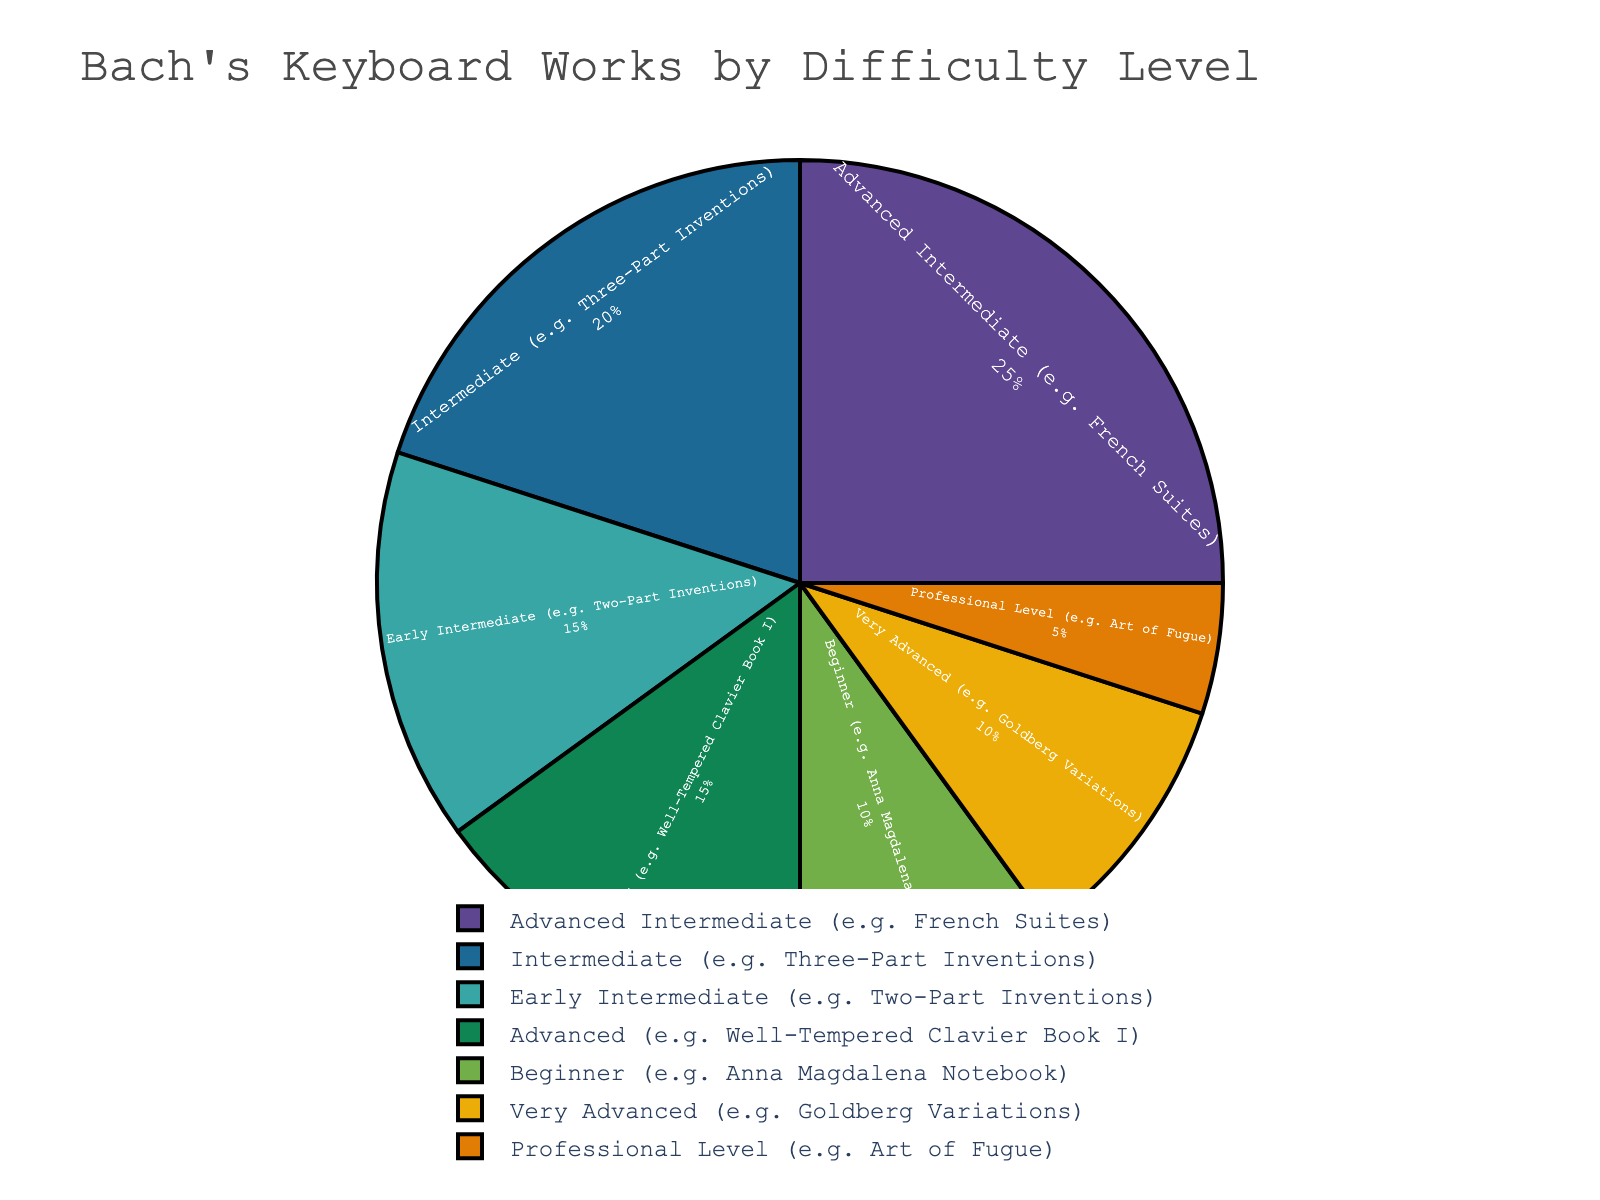What's the percentage of Bach's keyboard works that are at or below Intermediate level of difficulty? Sum the percentages of Beginner, Early Intermediate, and Intermediate levels. 10% (Beginner) + 15% (Early Intermediate) + 20% (Intermediate) = 45%
Answer: 45% Which difficulty level has the highest percentage of Bach's keyboard works? The chart shows that Advanced Intermediate has the highest percentage at 25%.
Answer: Advanced Intermediate Compare the total percentage of Very Advanced and Professional Level works. Is it higher than that of Advanced Intermediate? Sum the percentages for Very Advanced and Professional Level: 10% + 5% = 15%. This is less than 25% for Advanced Intermediate.
Answer: No Calculate the difference between the percentage of works at the Beginner level and the Professional Level. Subtract the percentage of Professional Level from Beginner: 10% (Beginner) - 5% (Professional Level) = 5%
Answer: 5% What percentage of Bach's keyboard works is more complex than Intermediate but less complex than Very Advanced? Sum the percentages of Advanced Intermediate and Advanced levels: 25% (Advanced Intermediate) + 15% (Advanced) = 40%
Answer: 40% Which levels of difficulty have exactly the same percentage of works? The chart shows that Early Intermediate and Advanced levels both have 15% each.
Answer: Early Intermediate and Advanced Compare the percentage of Advanced works to the sum of Beginner and Professional Level works. Which is greater? Sum the percentages of Beginner and Professional Level: 10% (Beginner) + 5% (Professional Level) = 15%. The percentage of Advanced works is also 15%, so they are equal.
Answer: Equal What is the combined percentage of Bach's keyboard works categorized as Advanced Intermediate and Very Advanced? Sum the percentages for Advanced Intermediate and Very Advanced levels: 25% (Advanced Intermediate) + 10% (Very Advanced) = 35%
Answer: 35% Rank the difficulty levels from the highest to the lowest percentage of works. List levels from highest to lowest percentage: Advanced Intermediate (25%), Intermediate (20%), Early Intermediate (15%), Advanced (15%), Beginner (10%), Very Advanced (10%), Professional Level (5%)
Answer: Advanced Intermediate, Intermediate, Early Intermediate, Advanced, Beginner, Very Advanced, Professional Level 